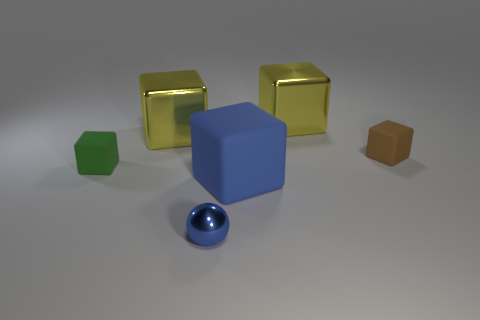There is a small green thing that is the same shape as the big blue matte thing; what is it made of?
Make the answer very short. Rubber. Is the small metal object the same shape as the tiny brown rubber object?
Offer a terse response. No. There is a small blue metal thing; what number of blue matte cubes are in front of it?
Ensure brevity in your answer.  0. The rubber object left of the metal thing in front of the tiny brown matte thing is what shape?
Keep it short and to the point. Cube. There is a tiny green thing that is the same material as the large blue thing; what shape is it?
Give a very brief answer. Cube. Do the object in front of the big blue cube and the cube in front of the tiny green rubber block have the same size?
Keep it short and to the point. No. What is the shape of the big yellow metal thing that is right of the tiny blue object?
Give a very brief answer. Cube. The tiny metal object has what color?
Offer a terse response. Blue. There is a green rubber block; does it have the same size as the shiny object that is on the right side of the small blue ball?
Ensure brevity in your answer.  No. How many shiny objects are red cylinders or tiny brown objects?
Ensure brevity in your answer.  0. 